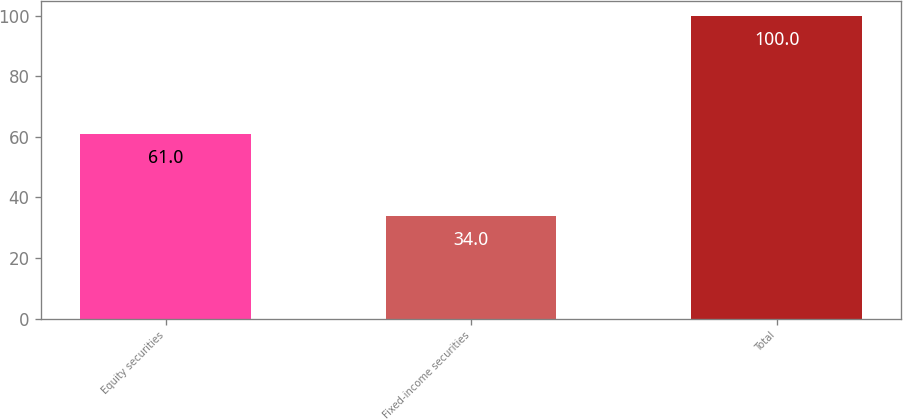Convert chart to OTSL. <chart><loc_0><loc_0><loc_500><loc_500><bar_chart><fcel>Equity securities<fcel>Fixed-income securities<fcel>Total<nl><fcel>61<fcel>34<fcel>100<nl></chart> 